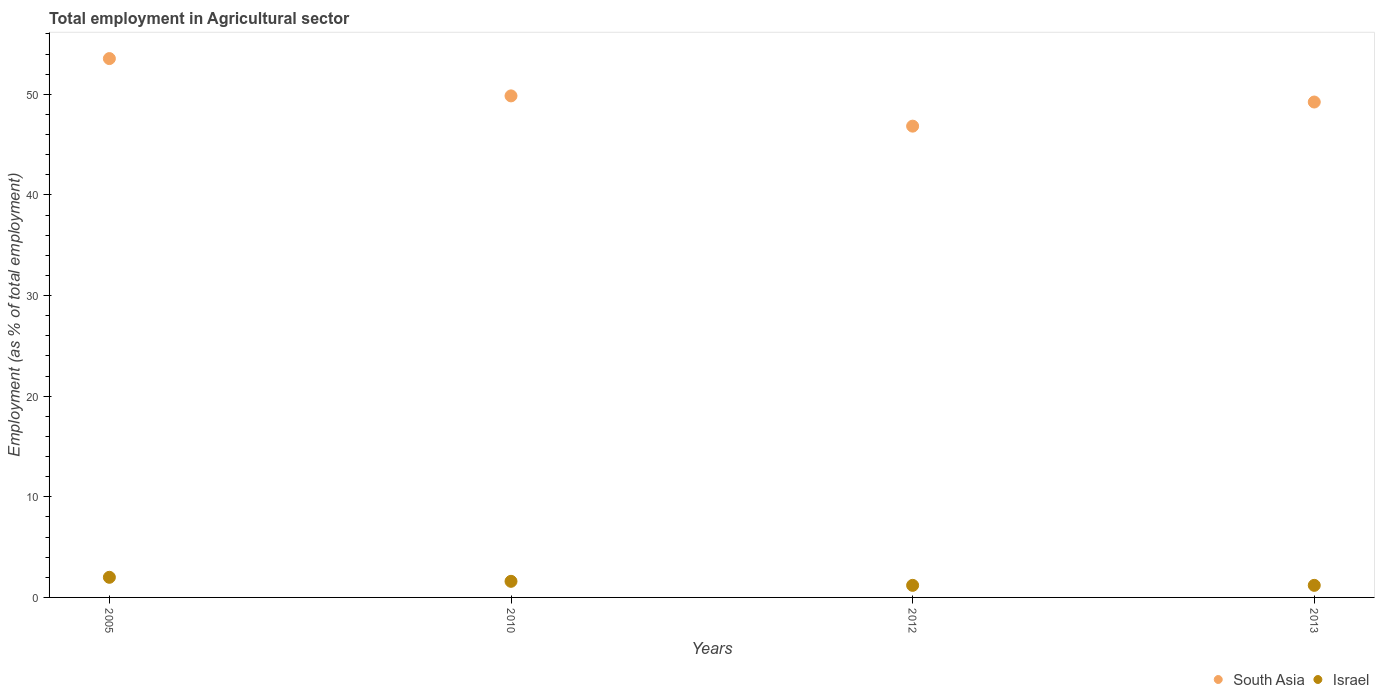How many different coloured dotlines are there?
Provide a succinct answer. 2. What is the employment in agricultural sector in Israel in 2010?
Ensure brevity in your answer.  1.6. Across all years, what is the minimum employment in agricultural sector in South Asia?
Your answer should be very brief. 46.84. In which year was the employment in agricultural sector in South Asia maximum?
Offer a terse response. 2005. What is the total employment in agricultural sector in South Asia in the graph?
Make the answer very short. 199.46. What is the difference between the employment in agricultural sector in Israel in 2010 and that in 2012?
Provide a short and direct response. 0.4. What is the difference between the employment in agricultural sector in South Asia in 2013 and the employment in agricultural sector in Israel in 2005?
Offer a terse response. 47.23. What is the average employment in agricultural sector in South Asia per year?
Keep it short and to the point. 49.87. In the year 2005, what is the difference between the employment in agricultural sector in Israel and employment in agricultural sector in South Asia?
Provide a short and direct response. -51.55. In how many years, is the employment in agricultural sector in South Asia greater than 54 %?
Keep it short and to the point. 0. What is the ratio of the employment in agricultural sector in South Asia in 2005 to that in 2012?
Provide a short and direct response. 1.14. What is the difference between the highest and the second highest employment in agricultural sector in South Asia?
Give a very brief answer. 3.71. What is the difference between the highest and the lowest employment in agricultural sector in Israel?
Your answer should be compact. 0.8. Does the employment in agricultural sector in Israel monotonically increase over the years?
Your answer should be very brief. No. What is the difference between two consecutive major ticks on the Y-axis?
Your answer should be compact. 10. Does the graph contain any zero values?
Ensure brevity in your answer.  No. Where does the legend appear in the graph?
Your answer should be compact. Bottom right. How many legend labels are there?
Provide a short and direct response. 2. What is the title of the graph?
Give a very brief answer. Total employment in Agricultural sector. What is the label or title of the X-axis?
Keep it short and to the point. Years. What is the label or title of the Y-axis?
Make the answer very short. Employment (as % of total employment). What is the Employment (as % of total employment) of South Asia in 2005?
Give a very brief answer. 53.55. What is the Employment (as % of total employment) of Israel in 2005?
Offer a terse response. 2. What is the Employment (as % of total employment) of South Asia in 2010?
Give a very brief answer. 49.84. What is the Employment (as % of total employment) of Israel in 2010?
Give a very brief answer. 1.6. What is the Employment (as % of total employment) in South Asia in 2012?
Offer a very short reply. 46.84. What is the Employment (as % of total employment) in Israel in 2012?
Ensure brevity in your answer.  1.2. What is the Employment (as % of total employment) of South Asia in 2013?
Give a very brief answer. 49.23. What is the Employment (as % of total employment) of Israel in 2013?
Your response must be concise. 1.2. Across all years, what is the maximum Employment (as % of total employment) of South Asia?
Ensure brevity in your answer.  53.55. Across all years, what is the maximum Employment (as % of total employment) in Israel?
Make the answer very short. 2. Across all years, what is the minimum Employment (as % of total employment) in South Asia?
Make the answer very short. 46.84. Across all years, what is the minimum Employment (as % of total employment) of Israel?
Provide a succinct answer. 1.2. What is the total Employment (as % of total employment) of South Asia in the graph?
Your answer should be very brief. 199.46. What is the total Employment (as % of total employment) in Israel in the graph?
Offer a terse response. 6. What is the difference between the Employment (as % of total employment) of South Asia in 2005 and that in 2010?
Provide a short and direct response. 3.71. What is the difference between the Employment (as % of total employment) of South Asia in 2005 and that in 2012?
Provide a short and direct response. 6.71. What is the difference between the Employment (as % of total employment) of South Asia in 2005 and that in 2013?
Give a very brief answer. 4.32. What is the difference between the Employment (as % of total employment) in Israel in 2005 and that in 2013?
Provide a short and direct response. 0.8. What is the difference between the Employment (as % of total employment) of South Asia in 2010 and that in 2012?
Offer a terse response. 3.01. What is the difference between the Employment (as % of total employment) in South Asia in 2010 and that in 2013?
Your answer should be very brief. 0.61. What is the difference between the Employment (as % of total employment) in South Asia in 2012 and that in 2013?
Ensure brevity in your answer.  -2.4. What is the difference between the Employment (as % of total employment) of Israel in 2012 and that in 2013?
Provide a succinct answer. 0. What is the difference between the Employment (as % of total employment) of South Asia in 2005 and the Employment (as % of total employment) of Israel in 2010?
Your answer should be compact. 51.95. What is the difference between the Employment (as % of total employment) in South Asia in 2005 and the Employment (as % of total employment) in Israel in 2012?
Your answer should be very brief. 52.35. What is the difference between the Employment (as % of total employment) in South Asia in 2005 and the Employment (as % of total employment) in Israel in 2013?
Your answer should be compact. 52.35. What is the difference between the Employment (as % of total employment) of South Asia in 2010 and the Employment (as % of total employment) of Israel in 2012?
Make the answer very short. 48.64. What is the difference between the Employment (as % of total employment) in South Asia in 2010 and the Employment (as % of total employment) in Israel in 2013?
Make the answer very short. 48.64. What is the difference between the Employment (as % of total employment) of South Asia in 2012 and the Employment (as % of total employment) of Israel in 2013?
Your answer should be very brief. 45.64. What is the average Employment (as % of total employment) in South Asia per year?
Provide a succinct answer. 49.87. What is the average Employment (as % of total employment) of Israel per year?
Ensure brevity in your answer.  1.5. In the year 2005, what is the difference between the Employment (as % of total employment) in South Asia and Employment (as % of total employment) in Israel?
Your response must be concise. 51.55. In the year 2010, what is the difference between the Employment (as % of total employment) of South Asia and Employment (as % of total employment) of Israel?
Your answer should be compact. 48.24. In the year 2012, what is the difference between the Employment (as % of total employment) of South Asia and Employment (as % of total employment) of Israel?
Provide a short and direct response. 45.64. In the year 2013, what is the difference between the Employment (as % of total employment) of South Asia and Employment (as % of total employment) of Israel?
Make the answer very short. 48.03. What is the ratio of the Employment (as % of total employment) of South Asia in 2005 to that in 2010?
Provide a short and direct response. 1.07. What is the ratio of the Employment (as % of total employment) of South Asia in 2005 to that in 2012?
Your answer should be compact. 1.14. What is the ratio of the Employment (as % of total employment) in South Asia in 2005 to that in 2013?
Your response must be concise. 1.09. What is the ratio of the Employment (as % of total employment) of Israel in 2005 to that in 2013?
Offer a very short reply. 1.67. What is the ratio of the Employment (as % of total employment) of South Asia in 2010 to that in 2012?
Offer a very short reply. 1.06. What is the ratio of the Employment (as % of total employment) of Israel in 2010 to that in 2012?
Your answer should be compact. 1.33. What is the ratio of the Employment (as % of total employment) of South Asia in 2010 to that in 2013?
Offer a terse response. 1.01. What is the ratio of the Employment (as % of total employment) in South Asia in 2012 to that in 2013?
Provide a short and direct response. 0.95. What is the ratio of the Employment (as % of total employment) of Israel in 2012 to that in 2013?
Keep it short and to the point. 1. What is the difference between the highest and the second highest Employment (as % of total employment) of South Asia?
Your answer should be compact. 3.71. What is the difference between the highest and the lowest Employment (as % of total employment) of South Asia?
Make the answer very short. 6.71. 